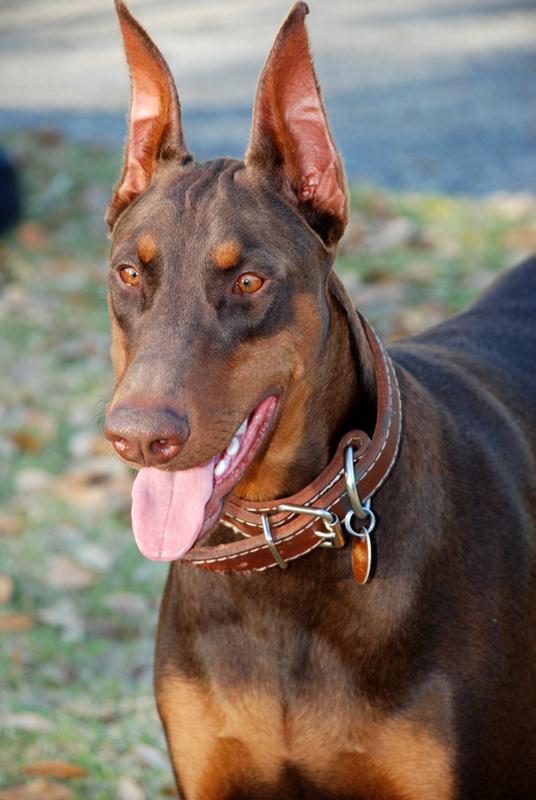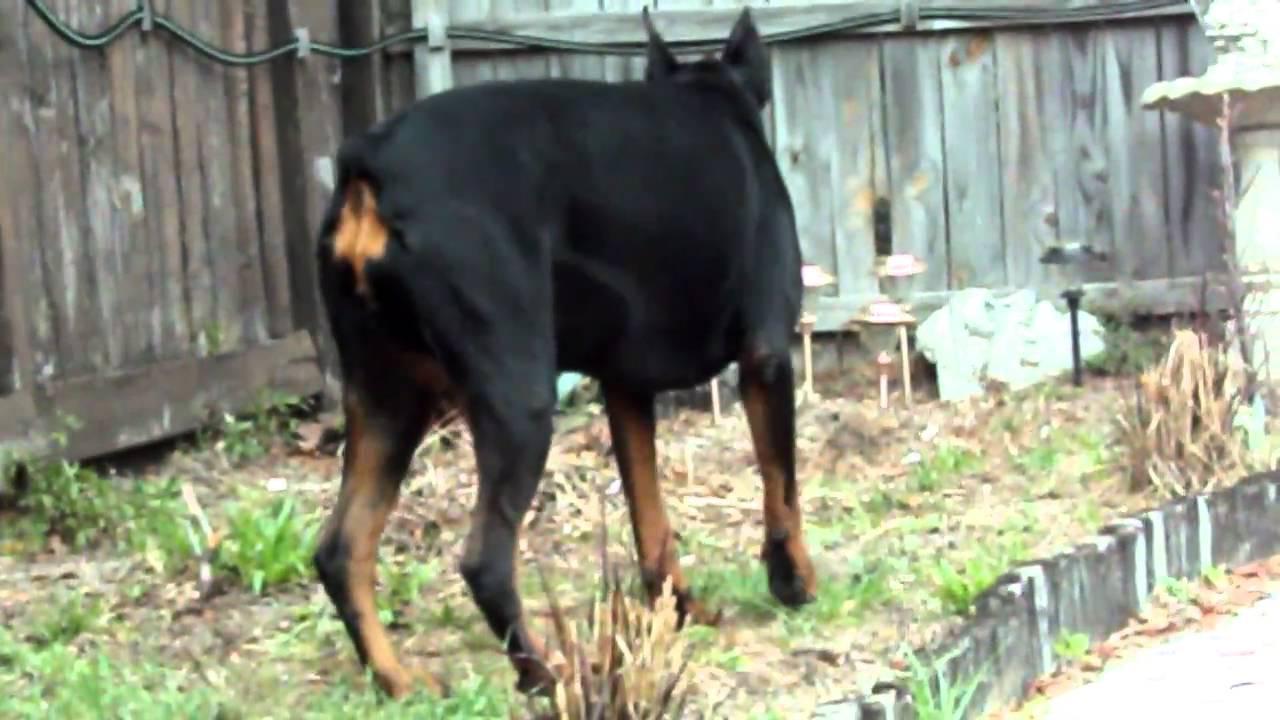The first image is the image on the left, the second image is the image on the right. For the images displayed, is the sentence "The right image contains exactly two dogs." factually correct? Answer yes or no. No. The first image is the image on the left, the second image is the image on the right. Analyze the images presented: Is the assertion "The left image shows two forward-turned dobermans with pointy ears and collars posed side-by-side, and the right image shows two dobermans interacting with their noses close together." valid? Answer yes or no. No. 